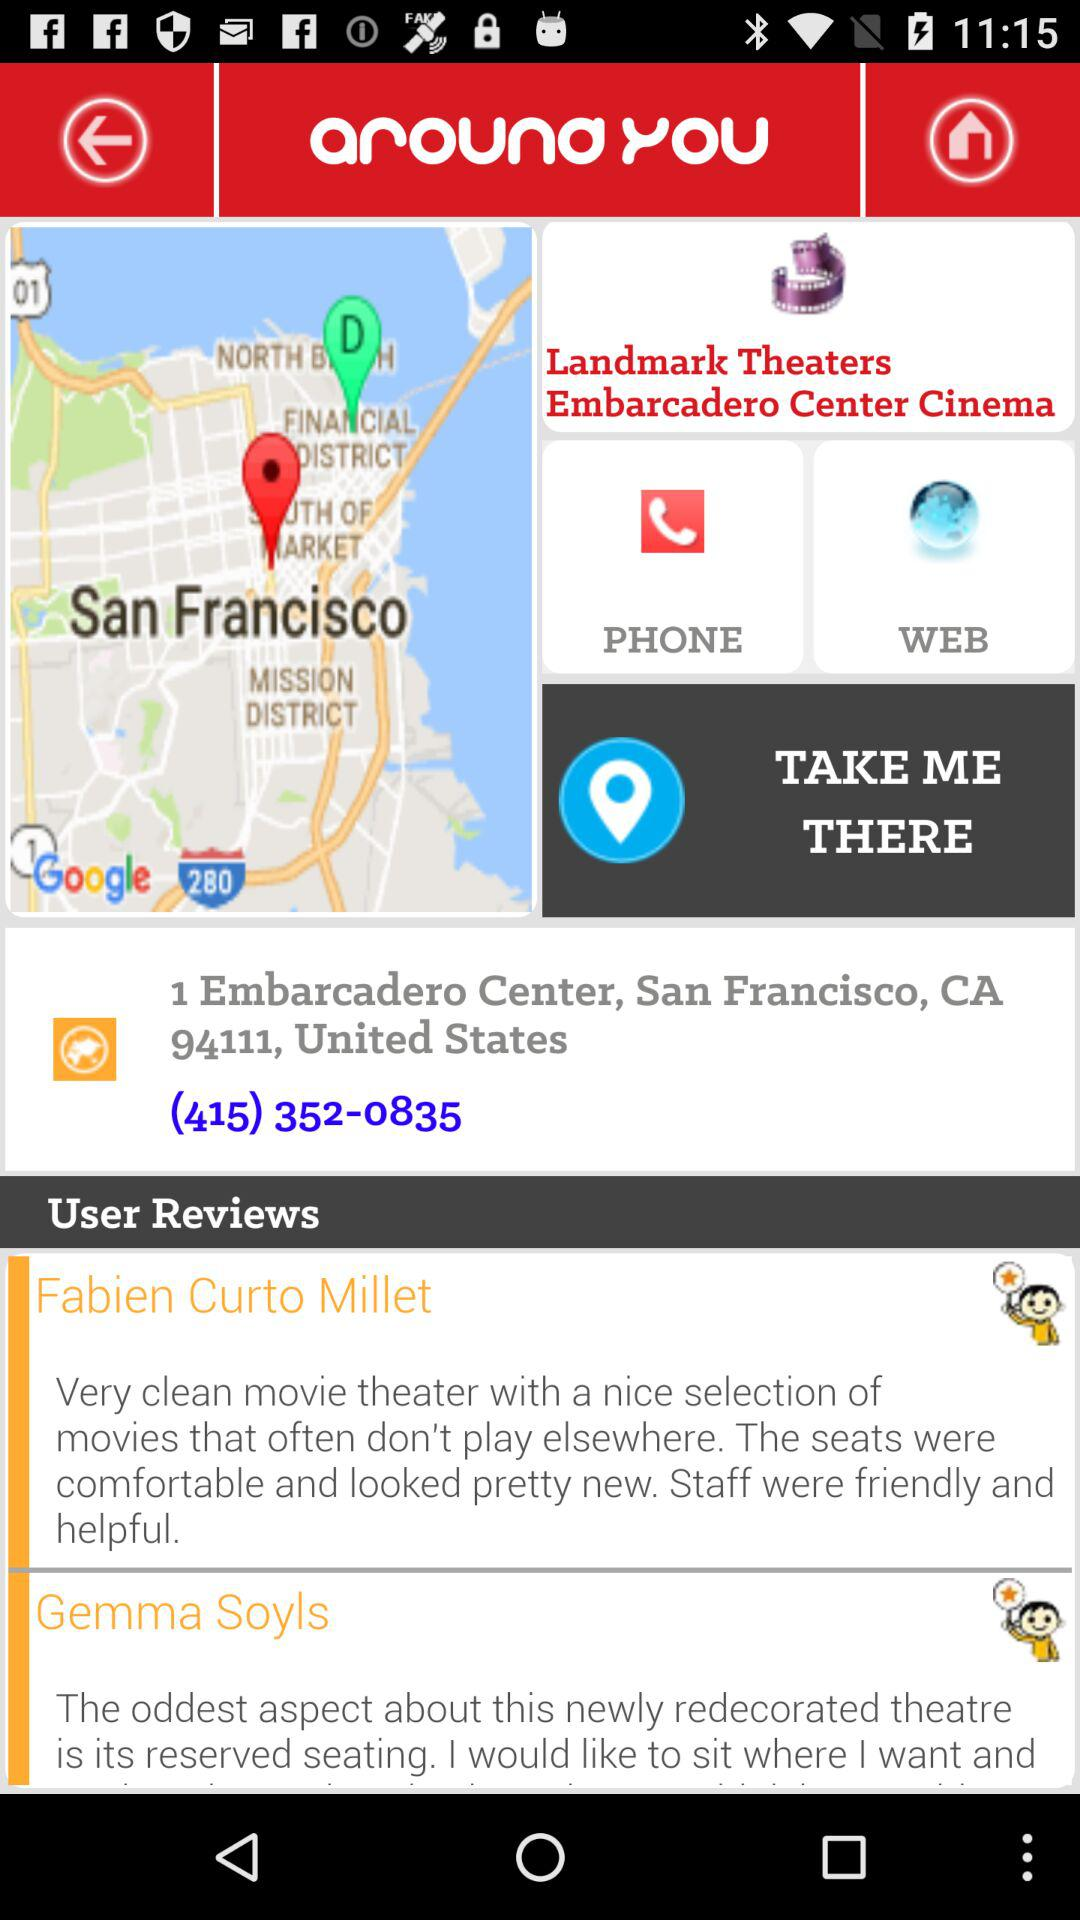What is the shown location? The shown location is 1 Embarcadero Center, San Francisco, CA 94111, United States. 